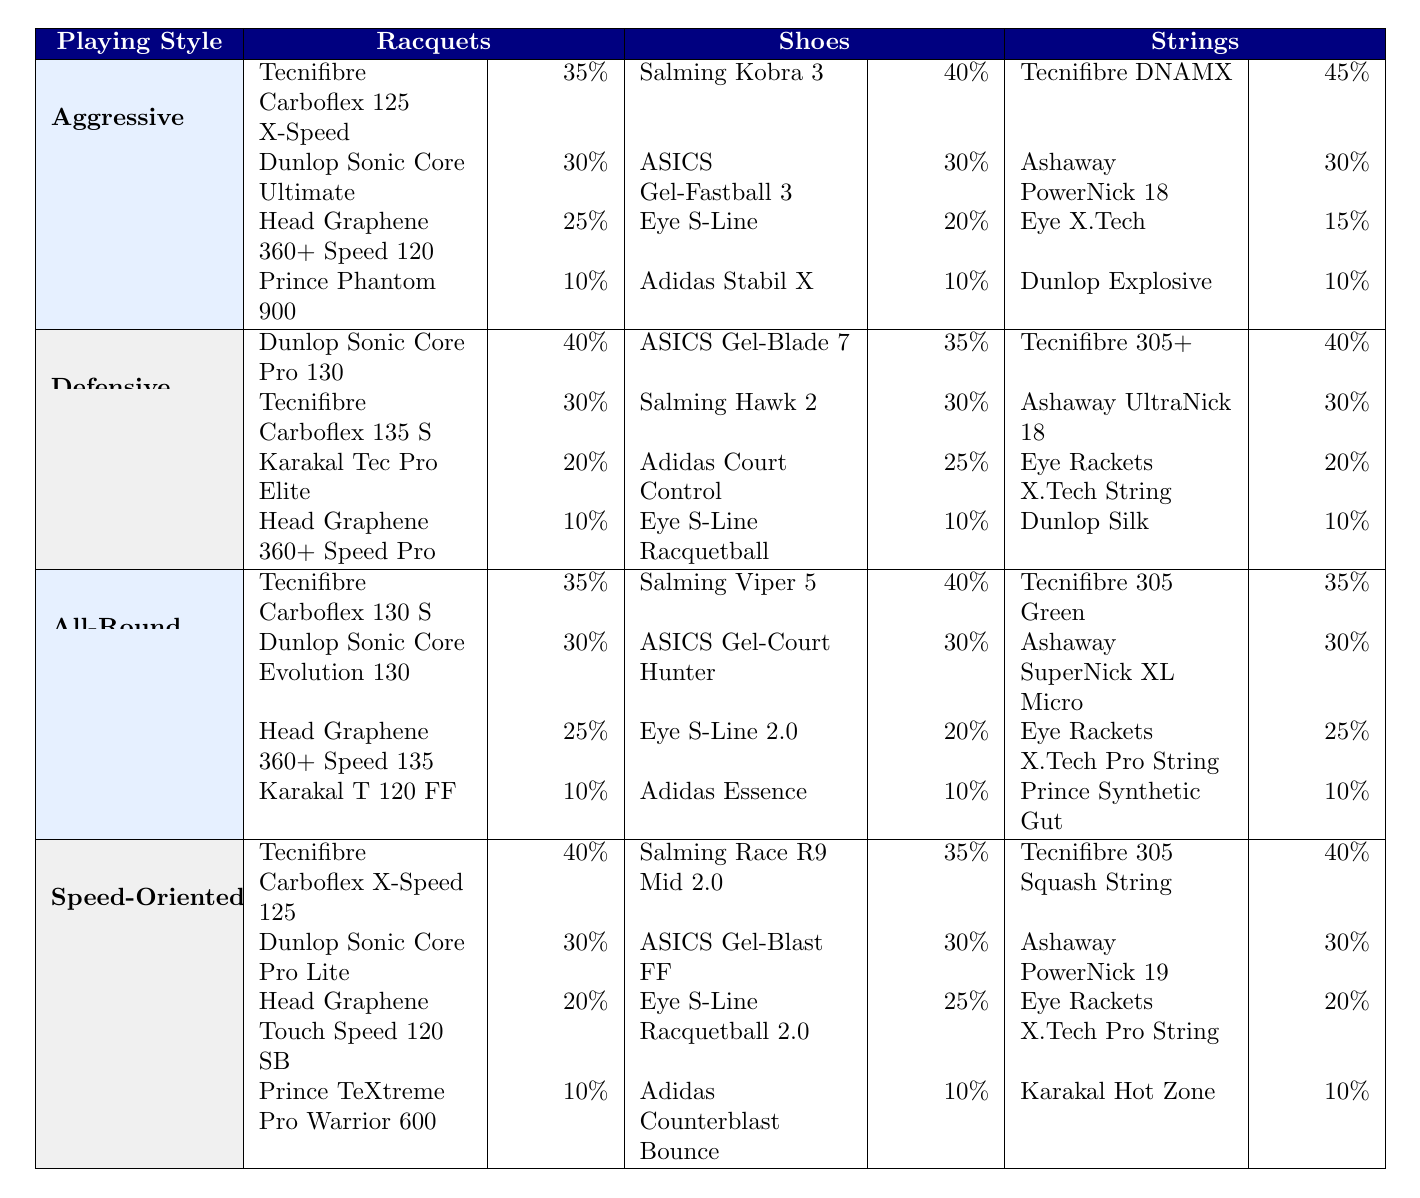What is the most popular racquet among aggressive players? The table shows that the most popular racquet among aggressive players is the Tecnifibre Carboflex 125 X-Speed, with a preference rate of 35%.
Answer: Tecnifibre Carboflex 125 X-Speed Which shoe has the lowest preference in the defensive category? In the defensive category, the shoe with the lowest preference is the Eye S-Line Racquetball, with a rate of 10%.
Answer: Eye S-Line Racquetball What is the percentage difference in preference between the top two racquets for all-round players? The top two racquets among all-round players are Tecnifibre Carboflex 130 S (35%) and Dunlop Sonic Core Evolution 130 (30%). The percentage difference is 35% - 30% = 5%.
Answer: 5% Is Ashaway PowerNick 18 more preferred than Eye X.Tech among aggressive players? Yes, Ashaway PowerNick 18 has a preference of 30%, while Eye X.Tech is preferred by only 15%.
Answer: Yes What is the total combined percentage of the top three strings used by speed-oriented players? The top three strings used by speed-oriented players are Tecnifibre 305 Squash String (40%), Ashaway PowerNick 19 (30%), and Eye Rackets X.Tech Pro String (20%). The total is 40% + 30% + 20% = 90%.
Answer: 90% How many more players prefer Salming Kobra 3 compared to Eye S-Line in the aggressive category? Salming Kobra 3 is preferred by 40% of players, while Eye S-Line is preferred by 20%. The difference is 40% - 20% = 20%.
Answer: 20% Which playing style uses the Tecnifibre 305+ string the most and what is its preference rate? The Tecnifibre 305+ string is most preferred by defensive players, with a preference rate of 40%.
Answer: Defensive players, 40% What is the average preference percentage for racquets in the all-round category? The preference rates for the all-round racquets are 35%, 30%, 25%, and 10%. The average is (35 + 30 + 25 + 10) / 4 = 100 / 4 = 25%.
Answer: 25% 